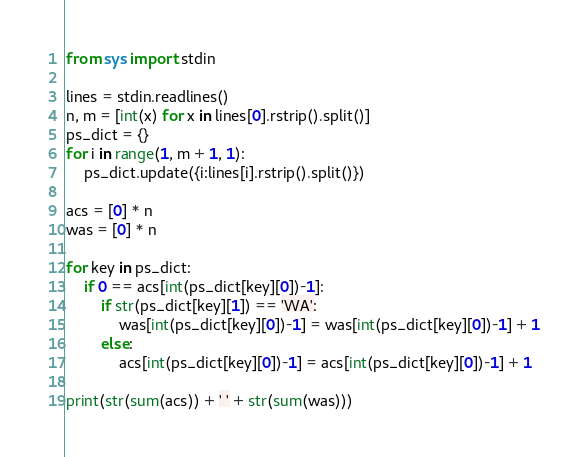<code> <loc_0><loc_0><loc_500><loc_500><_Python_>from sys import stdin

lines = stdin.readlines()
n, m = [int(x) for x in lines[0].rstrip().split()]
ps_dict = {}
for i in range(1, m + 1, 1):
    ps_dict.update({i:lines[i].rstrip().split()})

acs = [0] * n
was = [0] * n

for key in ps_dict:
    if 0 == acs[int(ps_dict[key][0])-1]:
        if str(ps_dict[key][1]) == 'WA':
            was[int(ps_dict[key][0])-1] = was[int(ps_dict[key][0])-1] + 1
        else:
            acs[int(ps_dict[key][0])-1] = acs[int(ps_dict[key][0])-1] + 1

print(str(sum(acs)) + ' ' + str(sum(was)))</code> 